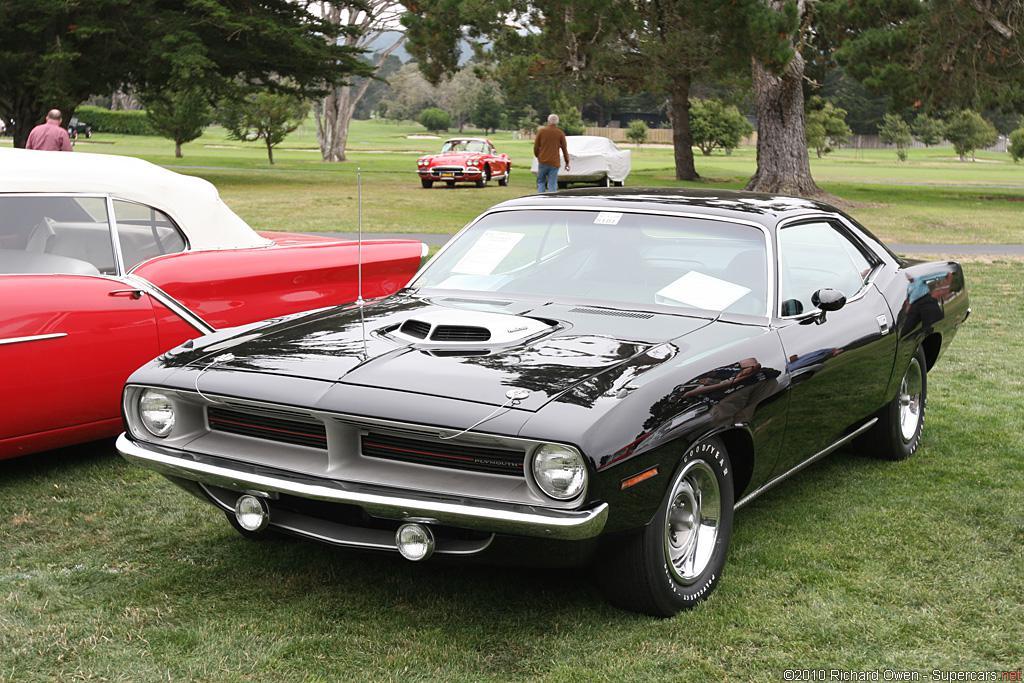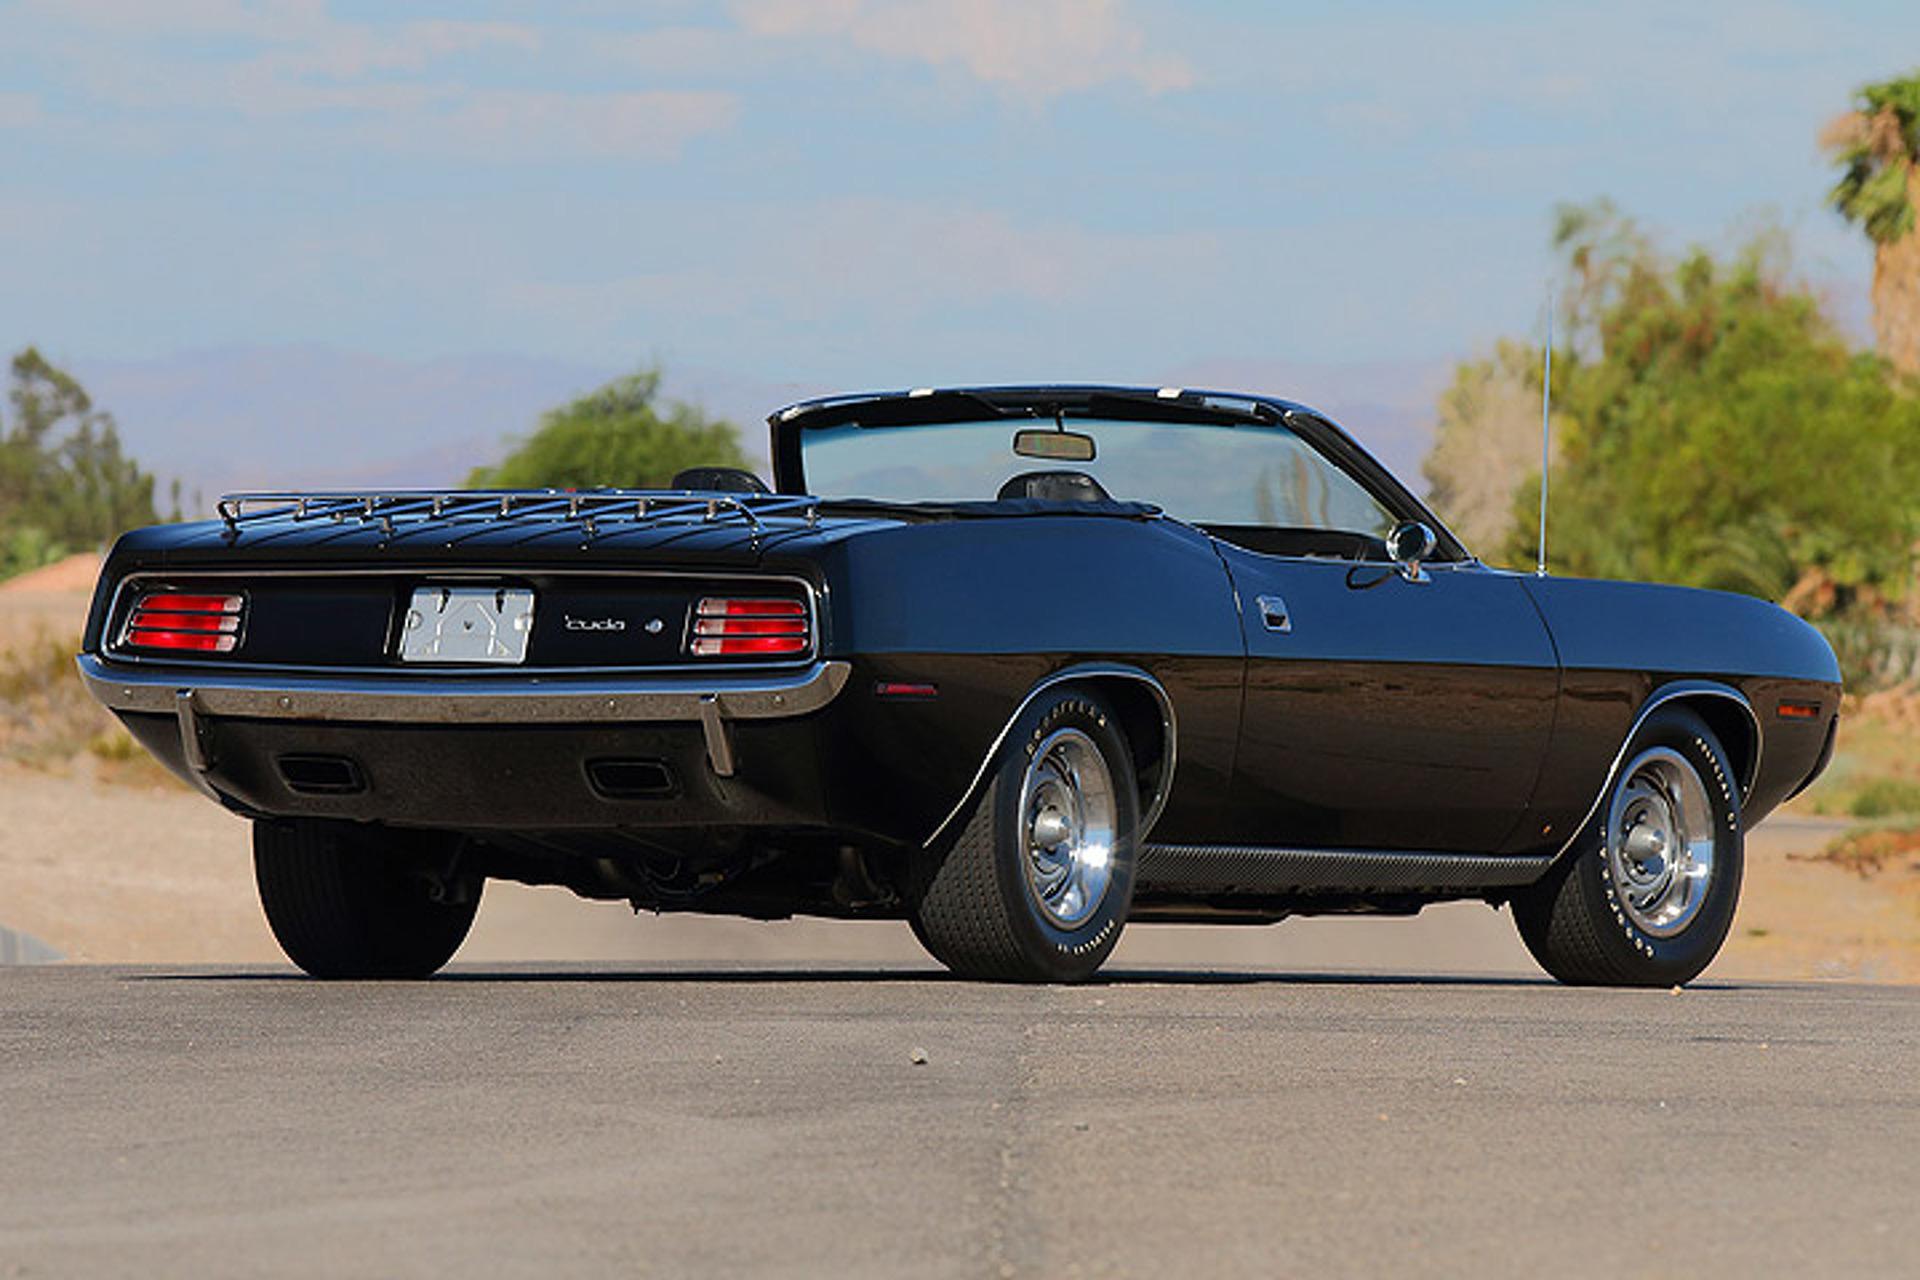The first image is the image on the left, the second image is the image on the right. Analyze the images presented: Is the assertion "At least one image features a yellow car in the foreground." valid? Answer yes or no. No. 